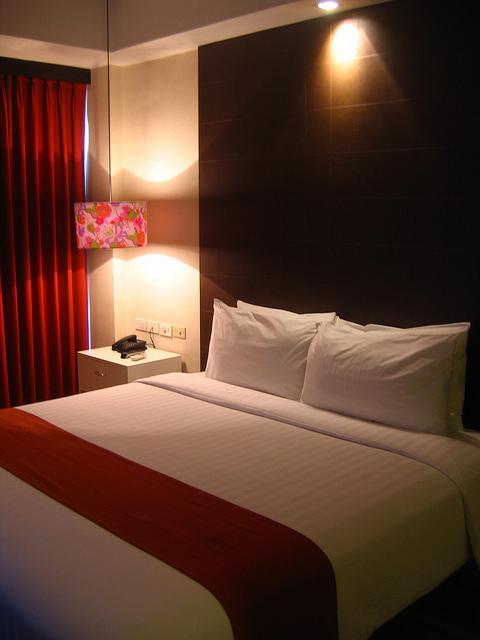Is this a double bed?
Keep it brief. Yes. What color are the sheets?
Answer briefly. White. How many pillows are on the bed?
Quick response, please. 4. What color are the curtains?
Write a very short answer. Red. 